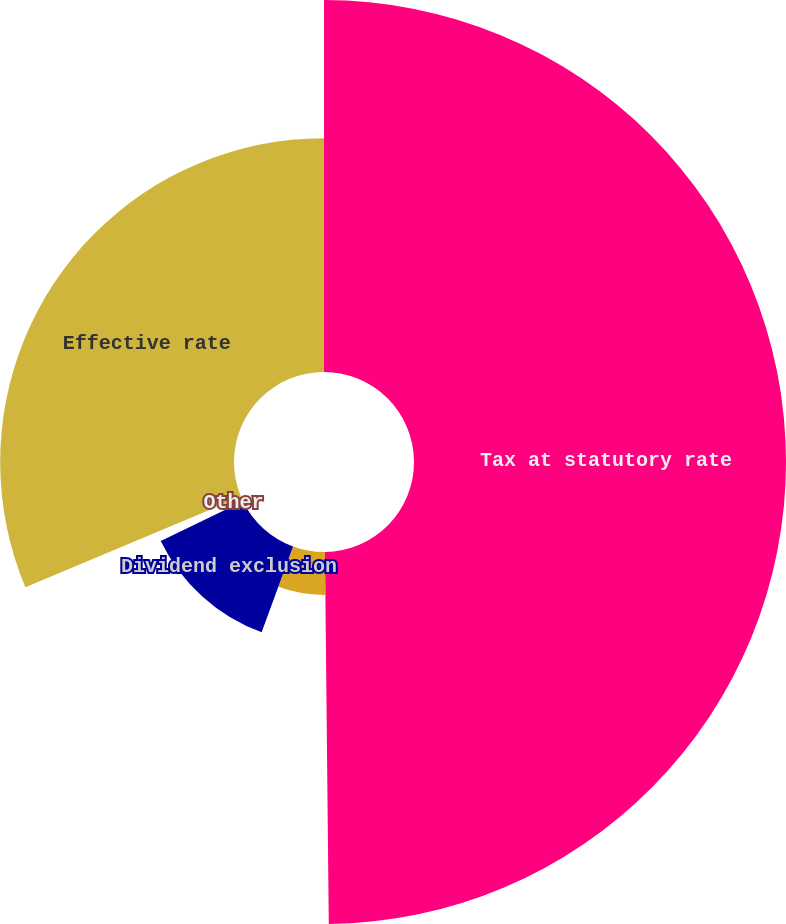Convert chart to OTSL. <chart><loc_0><loc_0><loc_500><loc_500><pie_chart><fcel>Tax at statutory rate<fcel>Tax-exempt municipal bonds<fcel>Dividend exclusion<fcel>Other<fcel>Effective rate<nl><fcel>49.83%<fcel>5.75%<fcel>12.24%<fcel>0.85%<fcel>31.32%<nl></chart> 